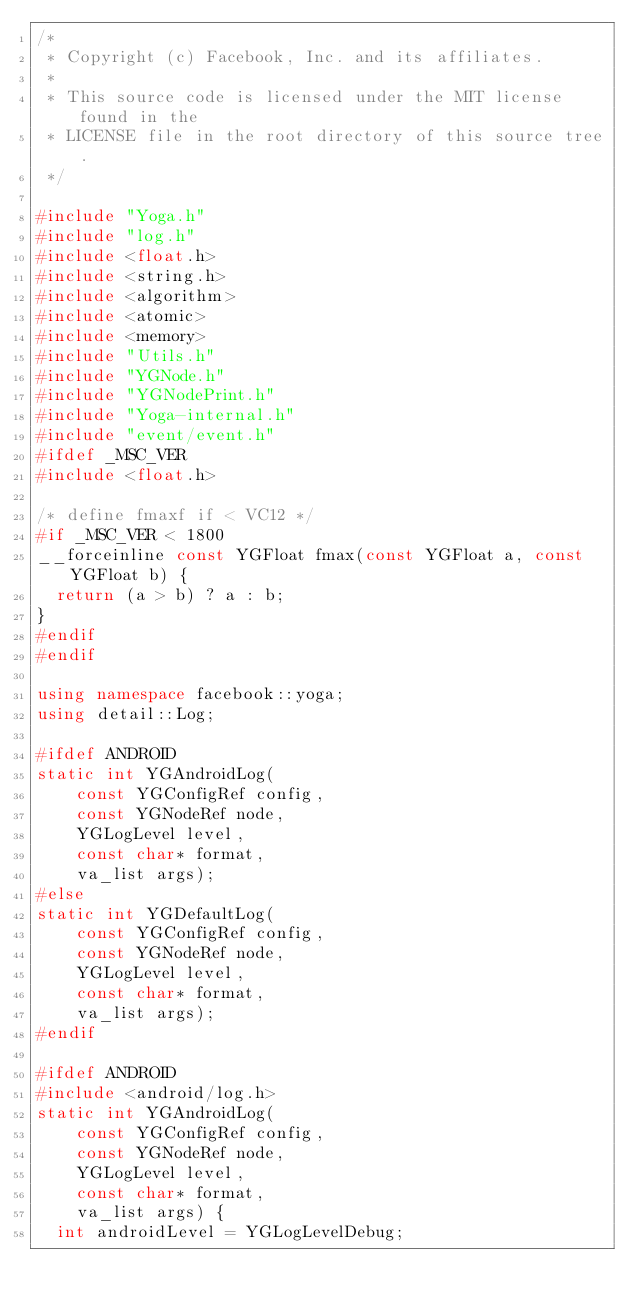Convert code to text. <code><loc_0><loc_0><loc_500><loc_500><_C++_>/*
 * Copyright (c) Facebook, Inc. and its affiliates.
 *
 * This source code is licensed under the MIT license found in the
 * LICENSE file in the root directory of this source tree.
 */

#include "Yoga.h"
#include "log.h"
#include <float.h>
#include <string.h>
#include <algorithm>
#include <atomic>
#include <memory>
#include "Utils.h"
#include "YGNode.h"
#include "YGNodePrint.h"
#include "Yoga-internal.h"
#include "event/event.h"
#ifdef _MSC_VER
#include <float.h>

/* define fmaxf if < VC12 */
#if _MSC_VER < 1800
__forceinline const YGFloat fmax(const YGFloat a, const YGFloat b) {
  return (a > b) ? a : b;
}
#endif
#endif

using namespace facebook::yoga;
using detail::Log;

#ifdef ANDROID
static int YGAndroidLog(
    const YGConfigRef config,
    const YGNodeRef node,
    YGLogLevel level,
    const char* format,
    va_list args);
#else
static int YGDefaultLog(
    const YGConfigRef config,
    const YGNodeRef node,
    YGLogLevel level,
    const char* format,
    va_list args);
#endif

#ifdef ANDROID
#include <android/log.h>
static int YGAndroidLog(
    const YGConfigRef config,
    const YGNodeRef node,
    YGLogLevel level,
    const char* format,
    va_list args) {
  int androidLevel = YGLogLevelDebug;</code> 